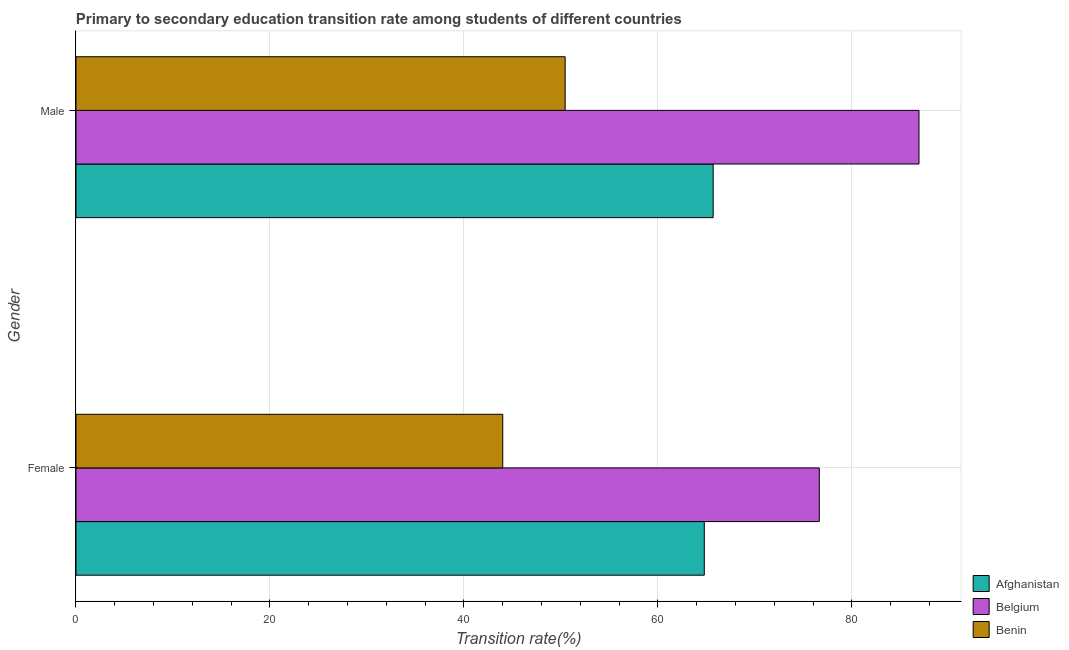Are the number of bars per tick equal to the number of legend labels?
Give a very brief answer. Yes. Are the number of bars on each tick of the Y-axis equal?
Offer a terse response. Yes. How many bars are there on the 1st tick from the top?
Ensure brevity in your answer.  3. How many bars are there on the 1st tick from the bottom?
Make the answer very short. 3. What is the transition rate among male students in Afghanistan?
Provide a short and direct response. 65.69. Across all countries, what is the maximum transition rate among male students?
Keep it short and to the point. 86.91. Across all countries, what is the minimum transition rate among male students?
Your response must be concise. 50.43. In which country was the transition rate among male students maximum?
Keep it short and to the point. Belgium. In which country was the transition rate among female students minimum?
Provide a short and direct response. Benin. What is the total transition rate among female students in the graph?
Give a very brief answer. 185.4. What is the difference between the transition rate among female students in Belgium and that in Benin?
Offer a very short reply. 32.63. What is the difference between the transition rate among male students in Belgium and the transition rate among female students in Afghanistan?
Keep it short and to the point. 22.13. What is the average transition rate among male students per country?
Keep it short and to the point. 67.68. What is the difference between the transition rate among male students and transition rate among female students in Benin?
Your answer should be compact. 6.43. In how many countries, is the transition rate among female students greater than 72 %?
Make the answer very short. 1. What is the ratio of the transition rate among male students in Belgium to that in Afghanistan?
Ensure brevity in your answer.  1.32. Is the transition rate among female students in Belgium less than that in Benin?
Your answer should be very brief. No. What does the 1st bar from the top in Male represents?
Offer a very short reply. Benin. What does the 3rd bar from the bottom in Male represents?
Your response must be concise. Benin. How many bars are there?
Offer a very short reply. 6. Are all the bars in the graph horizontal?
Offer a terse response. Yes. How many countries are there in the graph?
Your answer should be very brief. 3. Does the graph contain grids?
Give a very brief answer. Yes. Where does the legend appear in the graph?
Offer a very short reply. Bottom right. How are the legend labels stacked?
Make the answer very short. Vertical. What is the title of the graph?
Your response must be concise. Primary to secondary education transition rate among students of different countries. What is the label or title of the X-axis?
Provide a short and direct response. Transition rate(%). What is the label or title of the Y-axis?
Your response must be concise. Gender. What is the Transition rate(%) of Afghanistan in Female?
Make the answer very short. 64.78. What is the Transition rate(%) in Belgium in Female?
Your answer should be compact. 76.63. What is the Transition rate(%) of Benin in Female?
Keep it short and to the point. 44. What is the Transition rate(%) in Afghanistan in Male?
Provide a succinct answer. 65.69. What is the Transition rate(%) in Belgium in Male?
Your answer should be very brief. 86.91. What is the Transition rate(%) in Benin in Male?
Make the answer very short. 50.43. Across all Gender, what is the maximum Transition rate(%) in Afghanistan?
Give a very brief answer. 65.69. Across all Gender, what is the maximum Transition rate(%) of Belgium?
Provide a short and direct response. 86.91. Across all Gender, what is the maximum Transition rate(%) in Benin?
Offer a terse response. 50.43. Across all Gender, what is the minimum Transition rate(%) of Afghanistan?
Keep it short and to the point. 64.78. Across all Gender, what is the minimum Transition rate(%) in Belgium?
Offer a very short reply. 76.63. Across all Gender, what is the minimum Transition rate(%) in Benin?
Your response must be concise. 44. What is the total Transition rate(%) of Afghanistan in the graph?
Give a very brief answer. 130.47. What is the total Transition rate(%) of Belgium in the graph?
Your answer should be compact. 163.54. What is the total Transition rate(%) of Benin in the graph?
Give a very brief answer. 94.43. What is the difference between the Transition rate(%) of Afghanistan in Female and that in Male?
Keep it short and to the point. -0.91. What is the difference between the Transition rate(%) of Belgium in Female and that in Male?
Make the answer very short. -10.28. What is the difference between the Transition rate(%) in Benin in Female and that in Male?
Provide a short and direct response. -6.43. What is the difference between the Transition rate(%) of Afghanistan in Female and the Transition rate(%) of Belgium in Male?
Provide a short and direct response. -22.13. What is the difference between the Transition rate(%) of Afghanistan in Female and the Transition rate(%) of Benin in Male?
Provide a succinct answer. 14.34. What is the difference between the Transition rate(%) in Belgium in Female and the Transition rate(%) in Benin in Male?
Give a very brief answer. 26.2. What is the average Transition rate(%) in Afghanistan per Gender?
Ensure brevity in your answer.  65.23. What is the average Transition rate(%) of Belgium per Gender?
Your response must be concise. 81.77. What is the average Transition rate(%) in Benin per Gender?
Offer a very short reply. 47.21. What is the difference between the Transition rate(%) of Afghanistan and Transition rate(%) of Belgium in Female?
Your answer should be very brief. -11.86. What is the difference between the Transition rate(%) in Afghanistan and Transition rate(%) in Benin in Female?
Ensure brevity in your answer.  20.78. What is the difference between the Transition rate(%) in Belgium and Transition rate(%) in Benin in Female?
Provide a short and direct response. 32.63. What is the difference between the Transition rate(%) in Afghanistan and Transition rate(%) in Belgium in Male?
Ensure brevity in your answer.  -21.22. What is the difference between the Transition rate(%) in Afghanistan and Transition rate(%) in Benin in Male?
Keep it short and to the point. 15.26. What is the difference between the Transition rate(%) in Belgium and Transition rate(%) in Benin in Male?
Ensure brevity in your answer.  36.48. What is the ratio of the Transition rate(%) of Afghanistan in Female to that in Male?
Give a very brief answer. 0.99. What is the ratio of the Transition rate(%) in Belgium in Female to that in Male?
Ensure brevity in your answer.  0.88. What is the ratio of the Transition rate(%) of Benin in Female to that in Male?
Provide a short and direct response. 0.87. What is the difference between the highest and the second highest Transition rate(%) of Afghanistan?
Provide a succinct answer. 0.91. What is the difference between the highest and the second highest Transition rate(%) in Belgium?
Give a very brief answer. 10.28. What is the difference between the highest and the second highest Transition rate(%) of Benin?
Make the answer very short. 6.43. What is the difference between the highest and the lowest Transition rate(%) of Afghanistan?
Your response must be concise. 0.91. What is the difference between the highest and the lowest Transition rate(%) in Belgium?
Keep it short and to the point. 10.28. What is the difference between the highest and the lowest Transition rate(%) of Benin?
Your answer should be very brief. 6.43. 